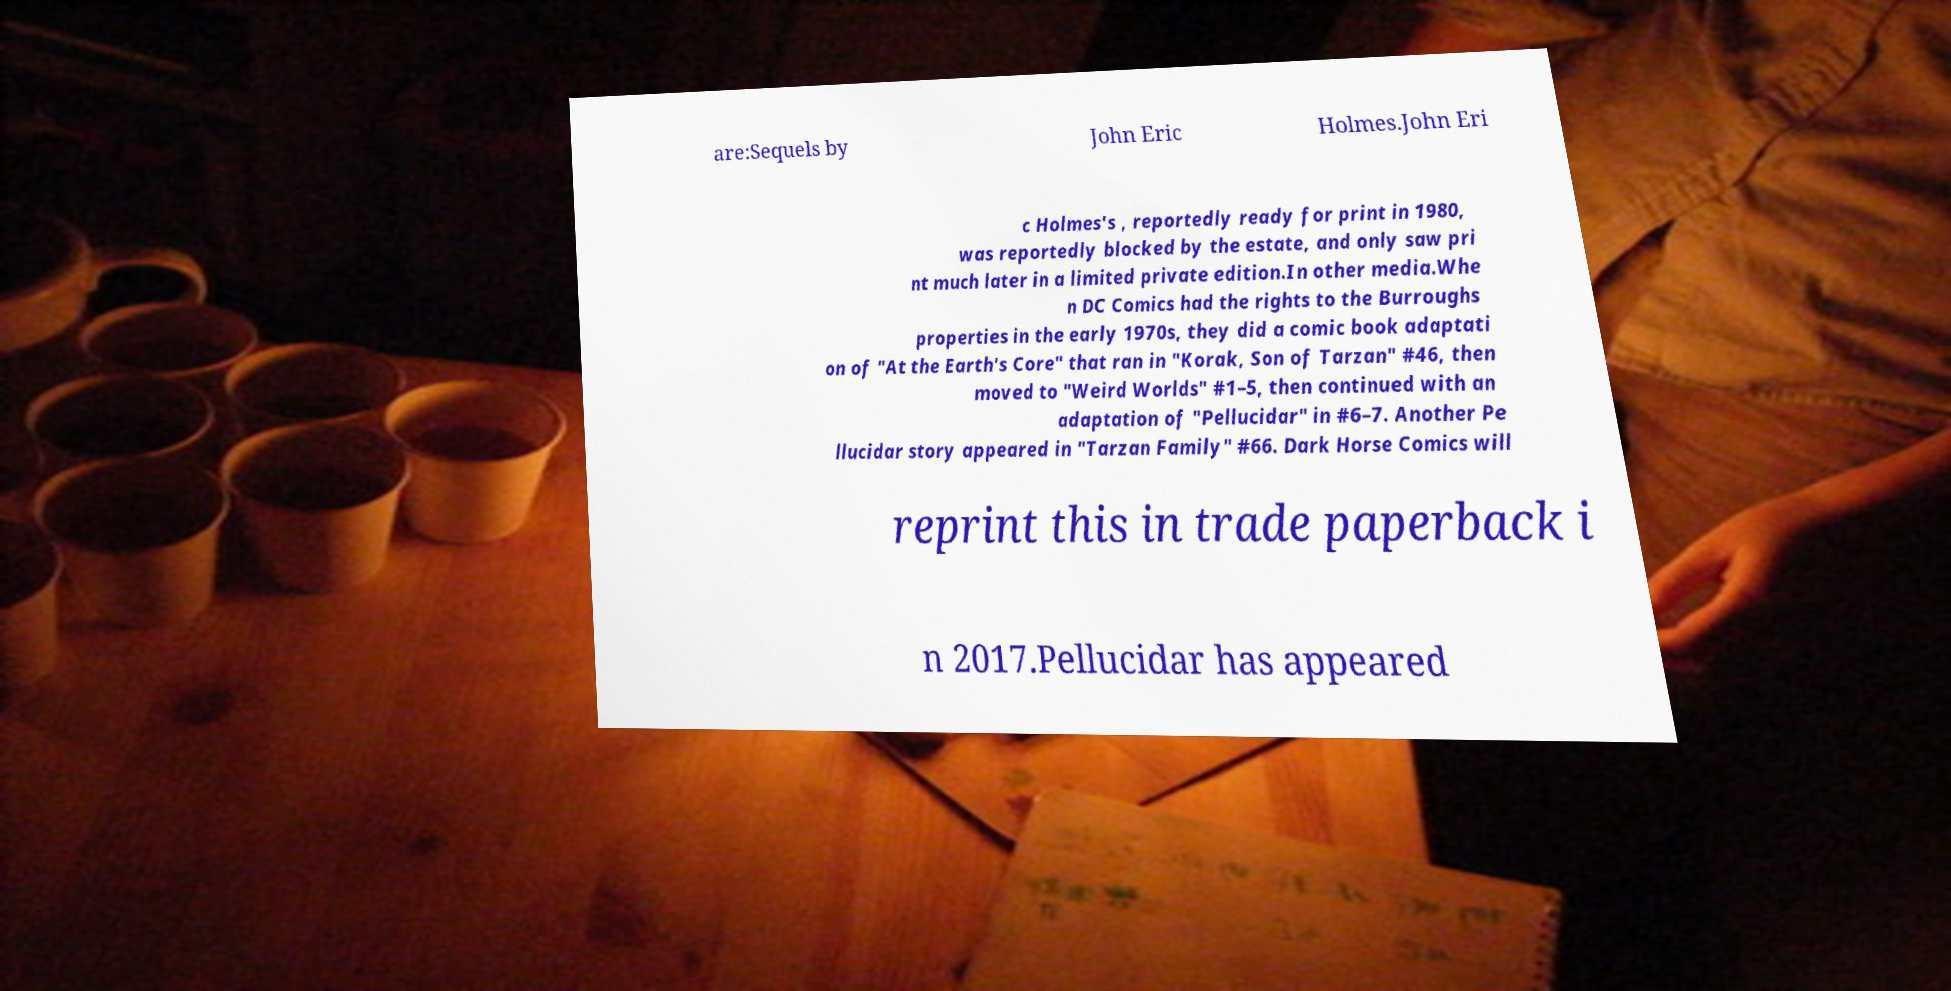There's text embedded in this image that I need extracted. Can you transcribe it verbatim? are:Sequels by John Eric Holmes.John Eri c Holmes's , reportedly ready for print in 1980, was reportedly blocked by the estate, and only saw pri nt much later in a limited private edition.In other media.Whe n DC Comics had the rights to the Burroughs properties in the early 1970s, they did a comic book adaptati on of "At the Earth's Core" that ran in "Korak, Son of Tarzan" #46, then moved to "Weird Worlds" #1–5, then continued with an adaptation of "Pellucidar" in #6–7. Another Pe llucidar story appeared in "Tarzan Family" #66. Dark Horse Comics will reprint this in trade paperback i n 2017.Pellucidar has appeared 